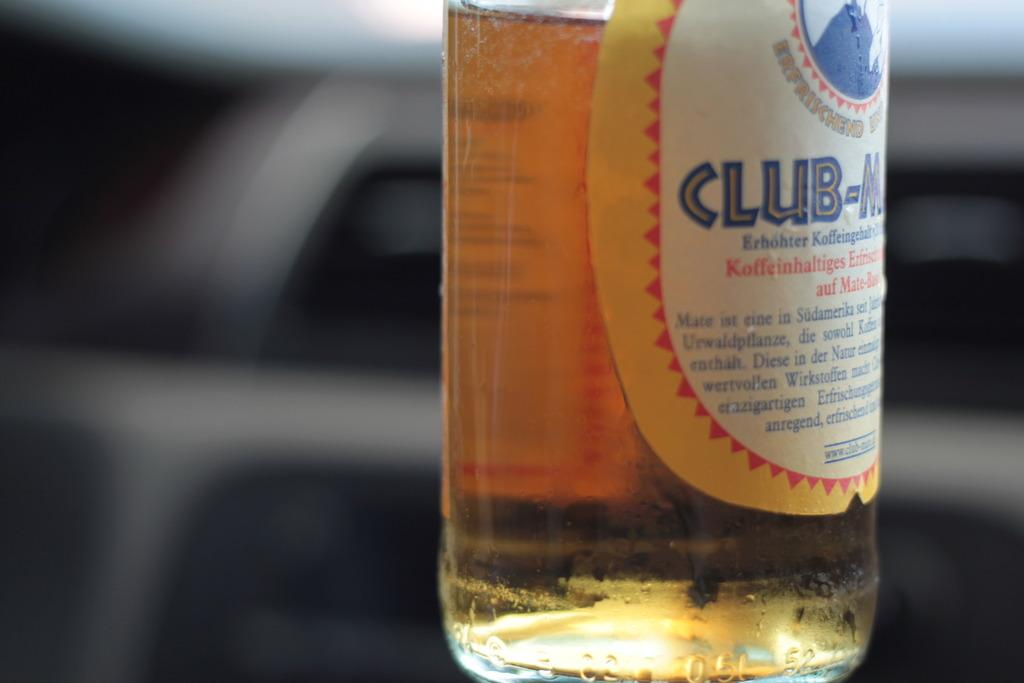<image>
Present a compact description of the photo's key features. a half full bottle of German Club-Mate beer 